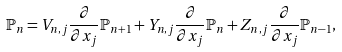<formula> <loc_0><loc_0><loc_500><loc_500>\mathbb { P } _ { n } = V _ { n , j } \frac { \partial } { \partial x _ { j } } \mathbb { P } _ { n + 1 } + Y _ { n , j } \frac { \partial } { \partial x _ { j } } \mathbb { P } _ { n } + Z _ { n , j } \frac { \partial } { \partial x _ { j } } \mathbb { P } _ { n - 1 } ,</formula> 